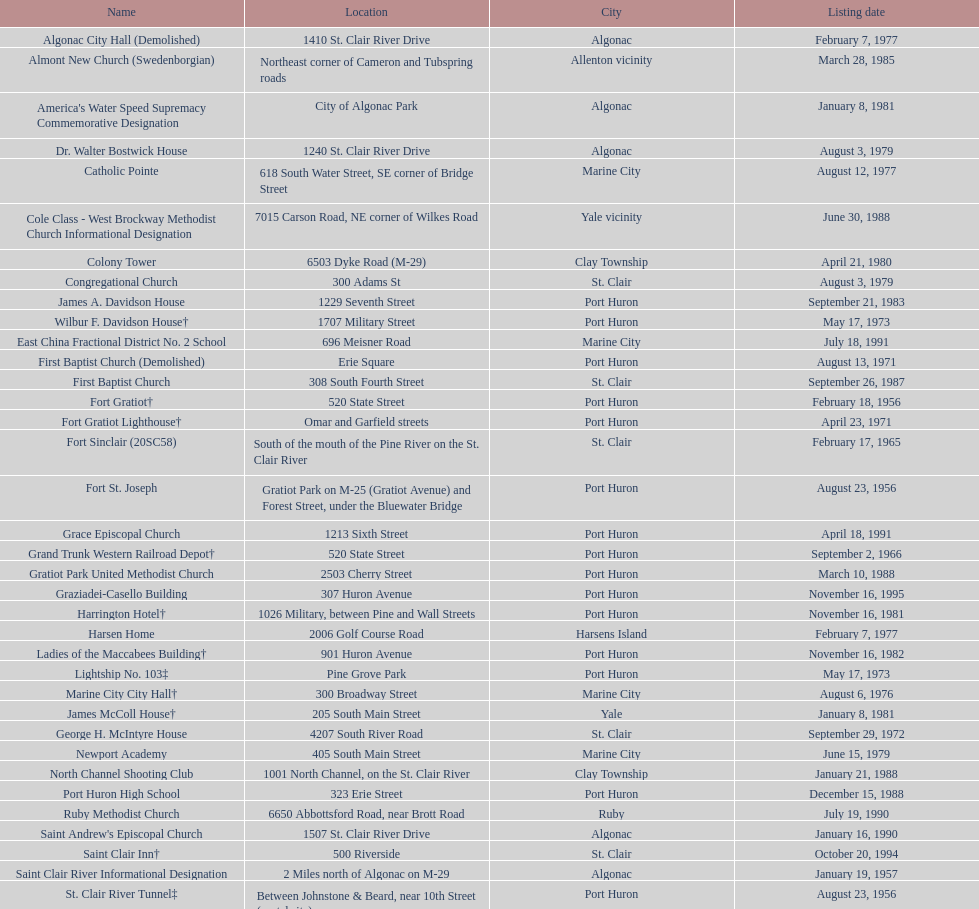In the city of algonac, what is the sum of all locations? 5. 